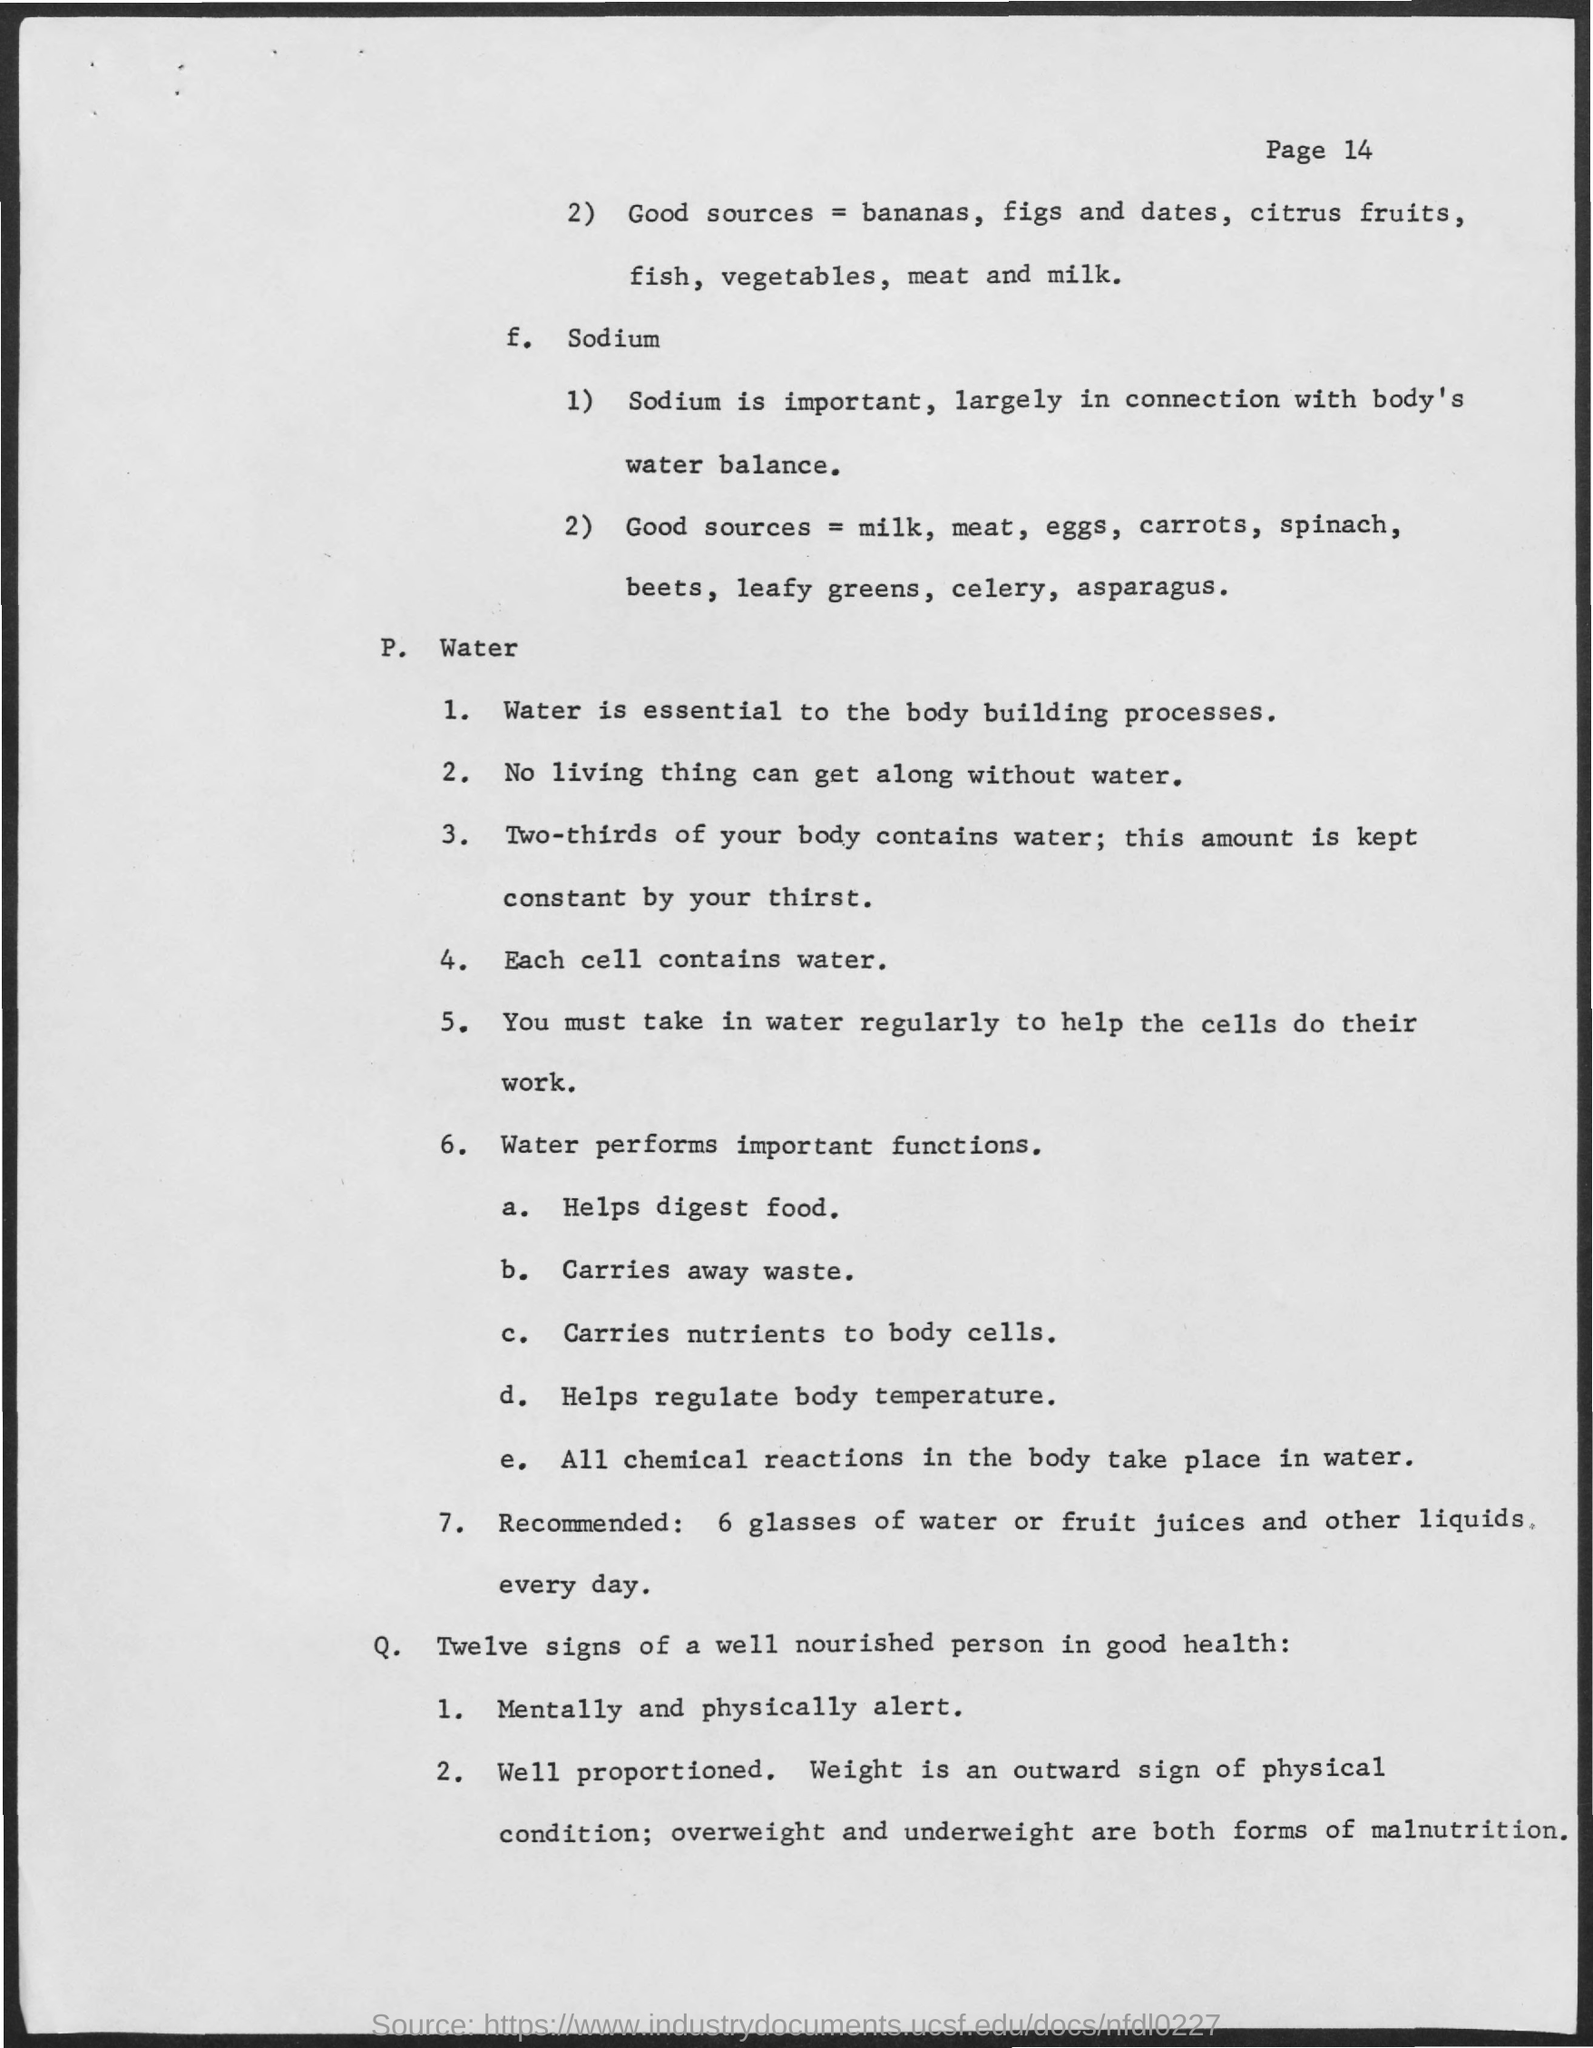Outline some significant characteristics in this image. Two-thirds of our body consists of water. Sodium is important for maintaining proper water balance in the body. Each cell contains water. 